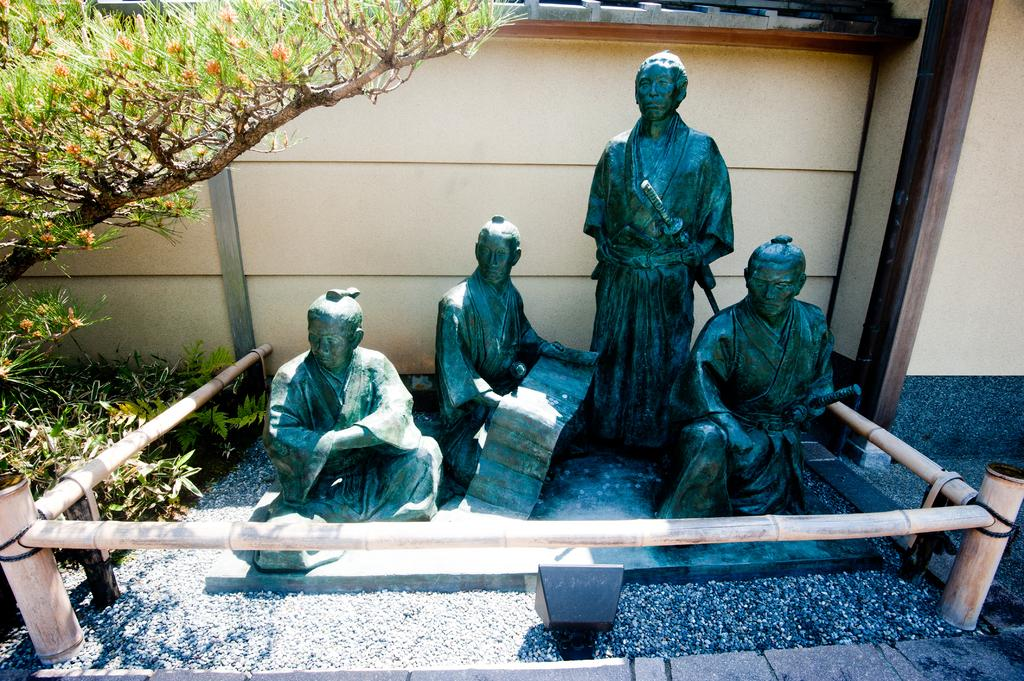What type of objects are depicted in the image? There are statues of persons in the image. What is the color of the statues? The statues are black in color. What surrounds the statues? There is railing around the statues. What can be seen providing illumination in the image? There is a light in the image. What type of plant is visible in the image? There is a tree in the image. What color is the wall in the image? There is a cream-colored wall in the image. What type of health advice can be seen on the wall in the image? There is no health advice visible on the wall in the image; it is a cream-colored wall with no text or images related to health. 